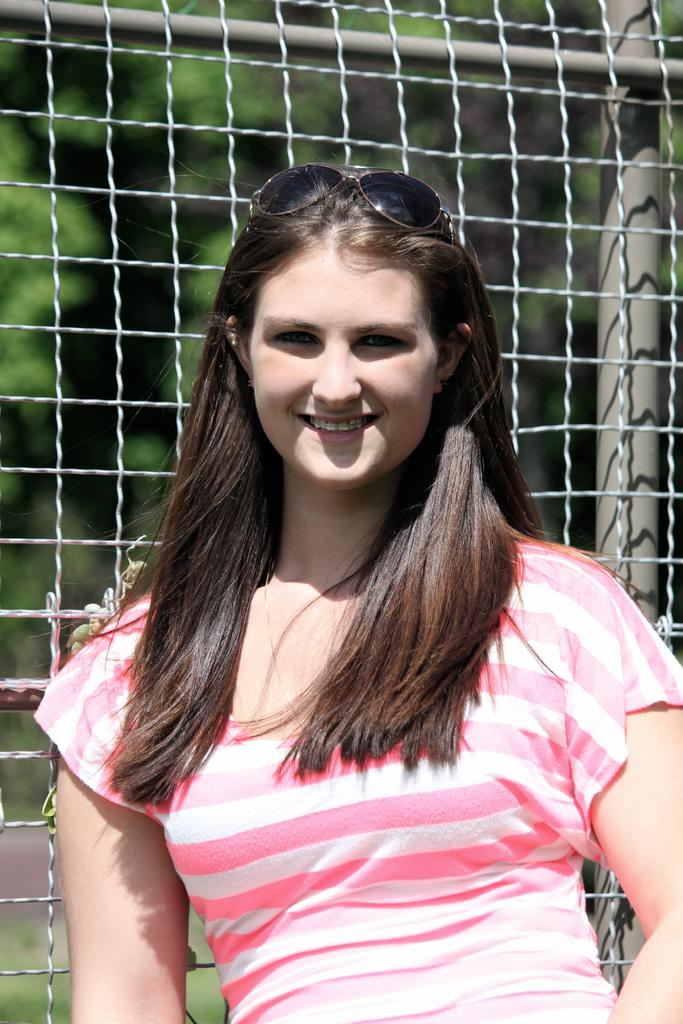Who is the main subject in the image? There is a lady in the image. What is the lady wearing? The lady is wearing a pink and white striped t-shirt. Are there any accessories visible on the lady? Yes, the lady is wearing sunglasses. What is the lady's facial expression? The lady is smiling. What can be seen behind the lady? There is a net behind the lady. What is visible in the background of the image? There are trees in the background of the image. What type of poison is the lady attempting to use in the image? There is no poison or any indication of an attempt to use poison in the image. 